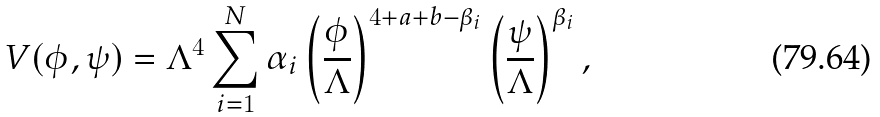<formula> <loc_0><loc_0><loc_500><loc_500>V ( \phi , \psi ) = \Lambda ^ { 4 } \sum _ { i = 1 } ^ { N } \alpha _ { i } \left ( \frac { \phi } { \Lambda } \right ) ^ { 4 + a + b - \beta _ { i } } \left ( \frac { \psi } { \Lambda } \right ) ^ { \beta _ { i } } ,</formula> 